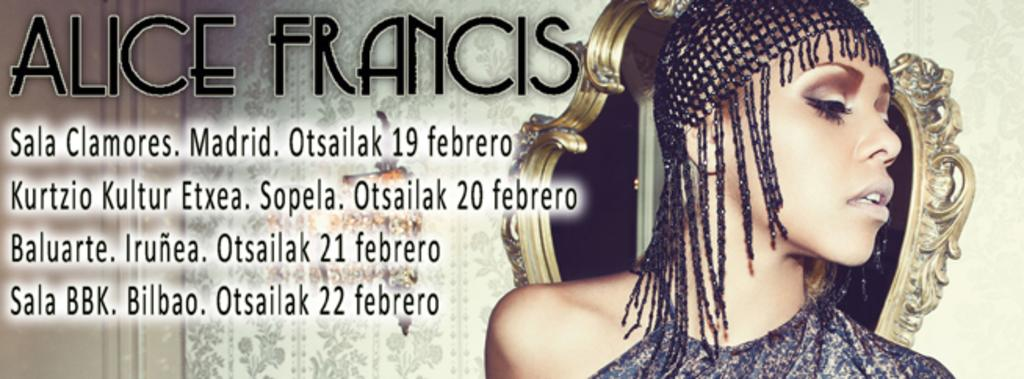What type of visual is the image? The image is a poster. Who or what is depicted on the poster? There is a woman depicted on the poster. What object is also shown on the poster? There is a mirror depicted on the poster. What else can be seen on the poster besides the woman and the mirror? There is some text present on the poster. How many pets can be seen in the image? There are no pets present in the image. What type of mine is visible in the image? There is no mine present in the image. 